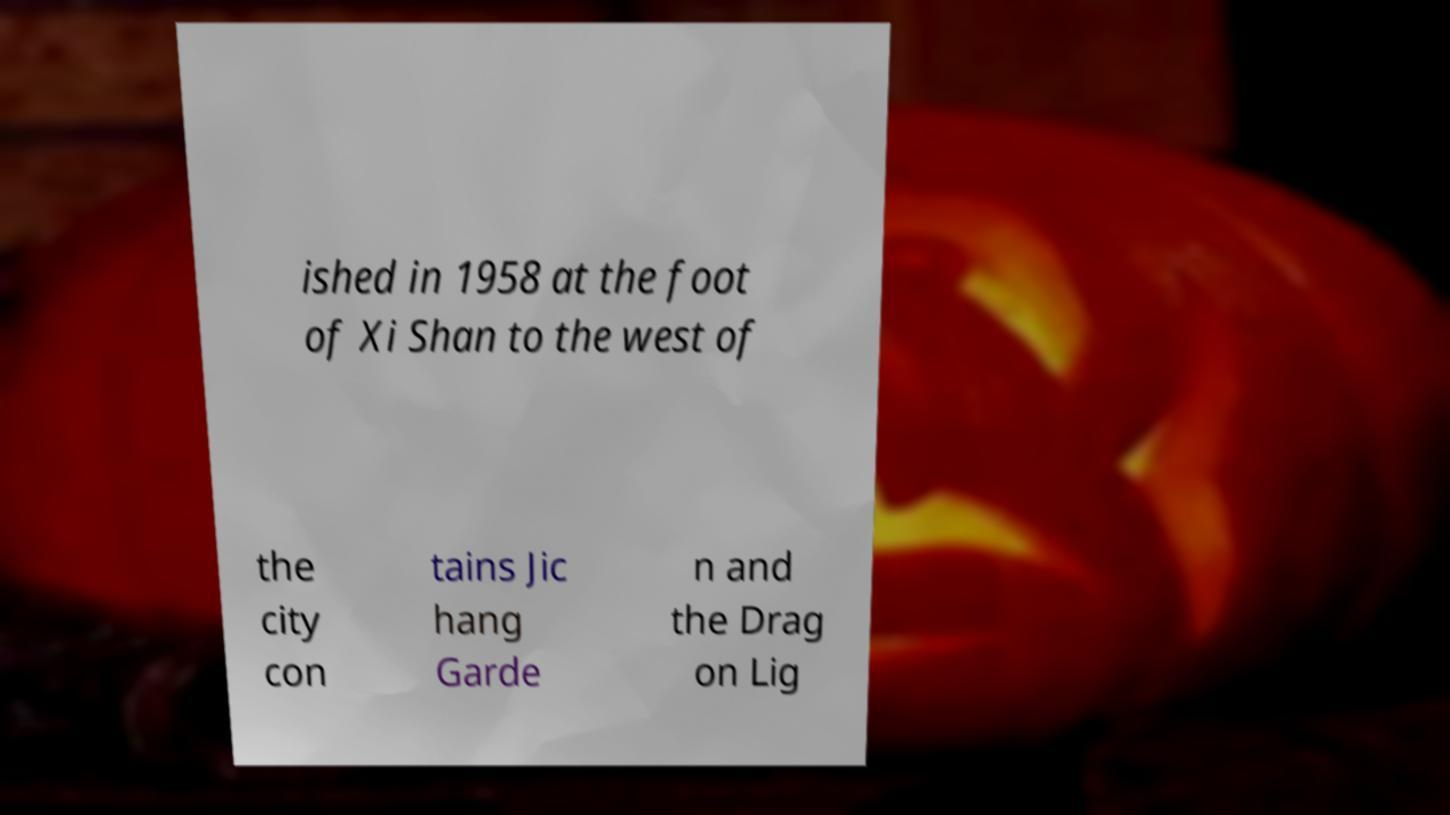Can you read and provide the text displayed in the image?This photo seems to have some interesting text. Can you extract and type it out for me? ished in 1958 at the foot of Xi Shan to the west of the city con tains Jic hang Garde n and the Drag on Lig 